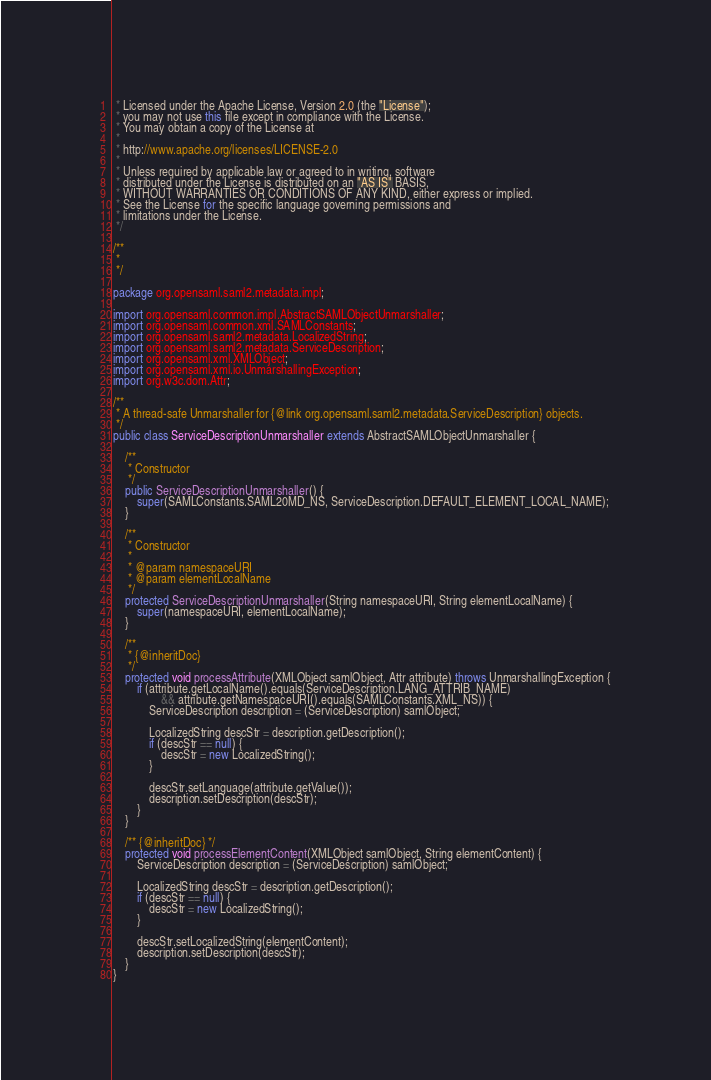Convert code to text. <code><loc_0><loc_0><loc_500><loc_500><_Java_> * Licensed under the Apache License, Version 2.0 (the "License");
 * you may not use this file except in compliance with the License.
 * You may obtain a copy of the License at
 *
 * http://www.apache.org/licenses/LICENSE-2.0
 *
 * Unless required by applicable law or agreed to in writing, software
 * distributed under the License is distributed on an "AS IS" BASIS,
 * WITHOUT WARRANTIES OR CONDITIONS OF ANY KIND, either express or implied.
 * See the License for the specific language governing permissions and
 * limitations under the License.
 */

/**
 * 
 */

package org.opensaml.saml2.metadata.impl;

import org.opensaml.common.impl.AbstractSAMLObjectUnmarshaller;
import org.opensaml.common.xml.SAMLConstants;
import org.opensaml.saml2.metadata.LocalizedString;
import org.opensaml.saml2.metadata.ServiceDescription;
import org.opensaml.xml.XMLObject;
import org.opensaml.xml.io.UnmarshallingException;
import org.w3c.dom.Attr;

/**
 * A thread-safe Unmarshaller for {@link org.opensaml.saml2.metadata.ServiceDescription} objects.
 */
public class ServiceDescriptionUnmarshaller extends AbstractSAMLObjectUnmarshaller {

    /**
     * Constructor
     */
    public ServiceDescriptionUnmarshaller() {
        super(SAMLConstants.SAML20MD_NS, ServiceDescription.DEFAULT_ELEMENT_LOCAL_NAME);
    }

    /**
     * Constructor
     * 
     * @param namespaceURI
     * @param elementLocalName
     */
    protected ServiceDescriptionUnmarshaller(String namespaceURI, String elementLocalName) {
        super(namespaceURI, elementLocalName);
    }
    
    /**
     * {@inheritDoc}
     */
    protected void processAttribute(XMLObject samlObject, Attr attribute) throws UnmarshallingException {
        if (attribute.getLocalName().equals(ServiceDescription.LANG_ATTRIB_NAME)
                && attribute.getNamespaceURI().equals(SAMLConstants.XML_NS)) {
            ServiceDescription description = (ServiceDescription) samlObject;

            LocalizedString descStr = description.getDescription();
            if (descStr == null) {
                descStr = new LocalizedString();
            }

            descStr.setLanguage(attribute.getValue());
            description.setDescription(descStr);
        }
    }

    /** {@inheritDoc} */
    protected void processElementContent(XMLObject samlObject, String elementContent) {
        ServiceDescription description = (ServiceDescription) samlObject;

        LocalizedString descStr = description.getDescription();
        if (descStr == null) {
            descStr = new LocalizedString();
        }

        descStr.setLocalizedString(elementContent);
        description.setDescription(descStr);
    }
}</code> 